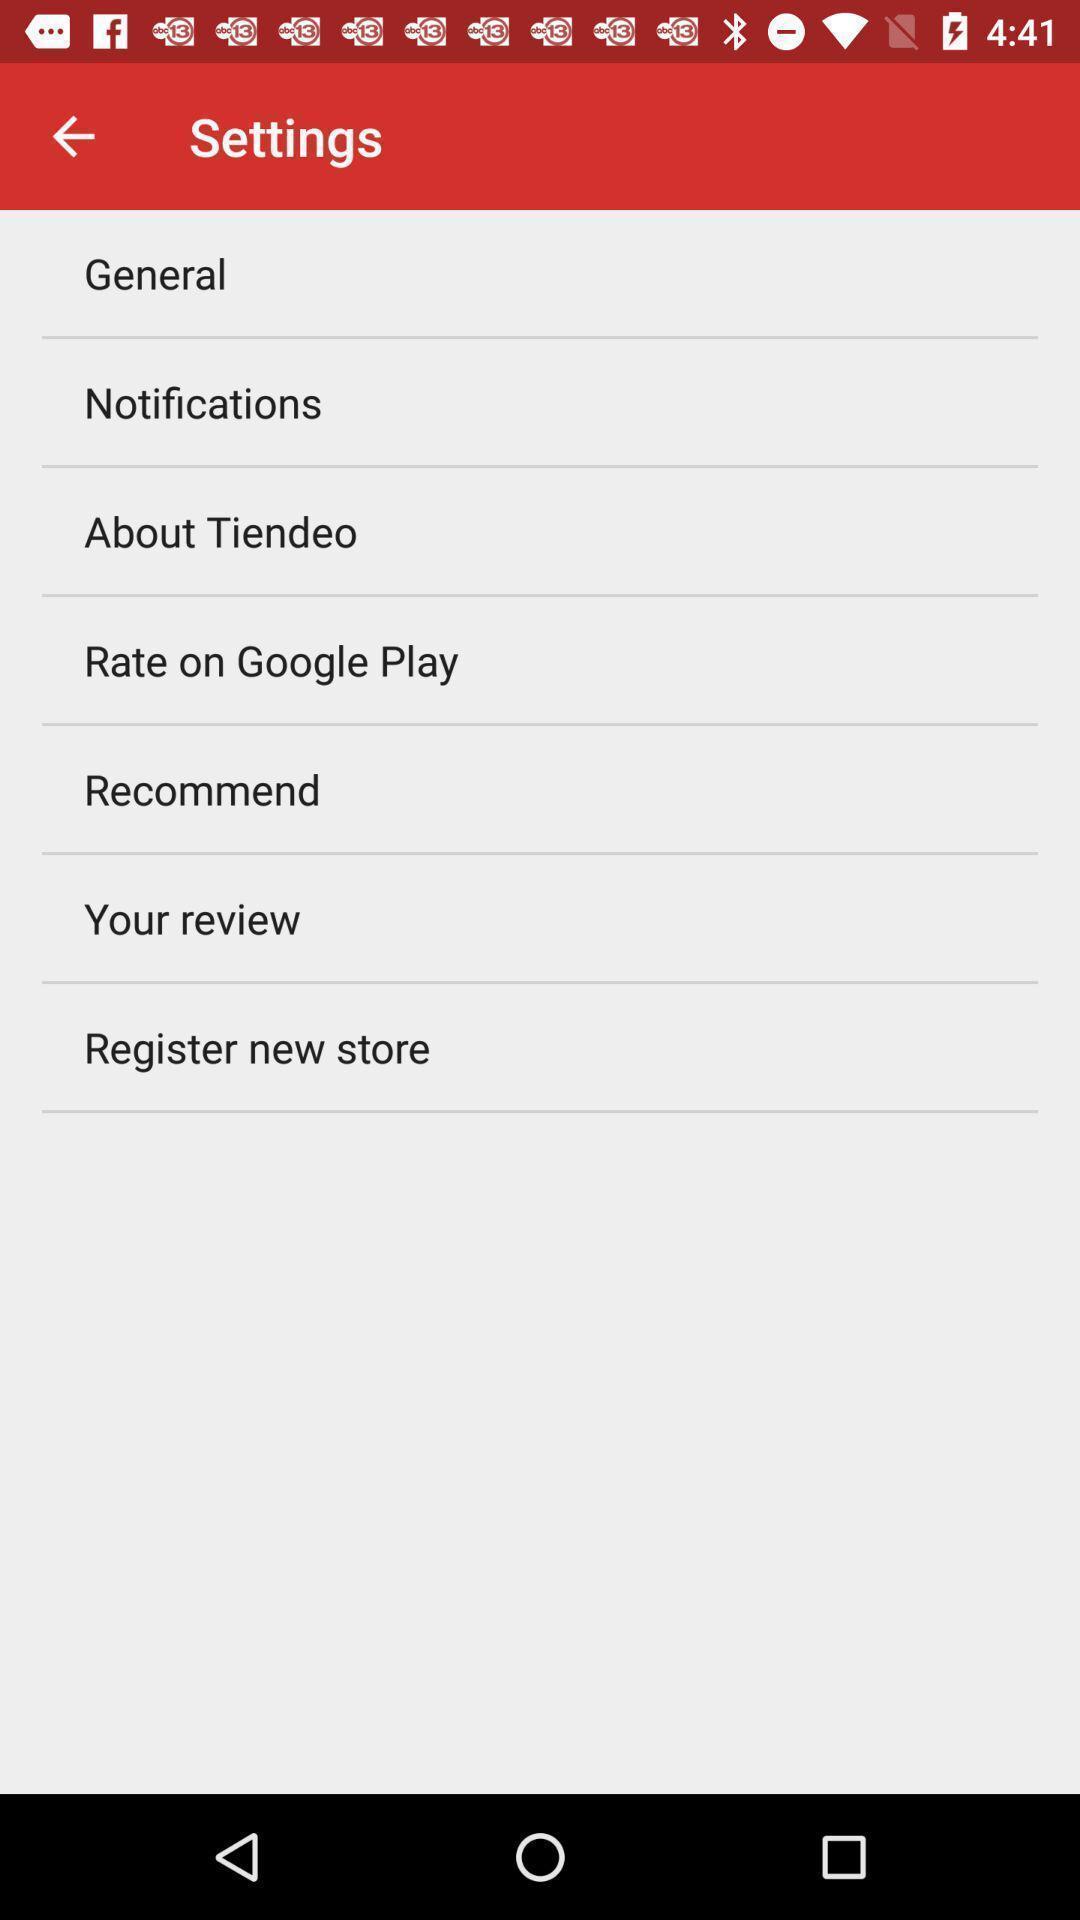Summarize the main components in this picture. Settings page. 